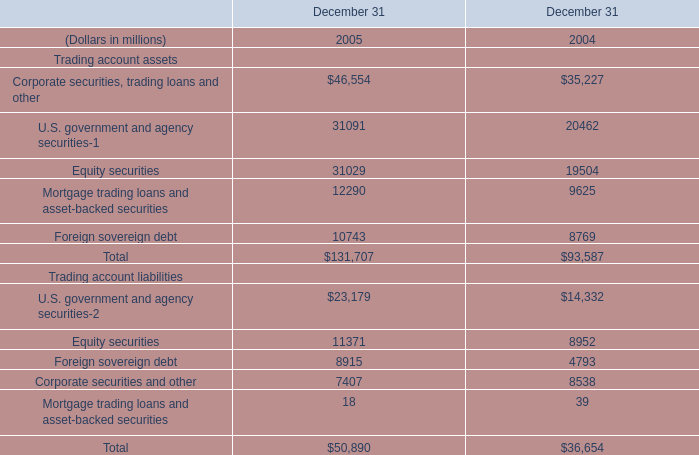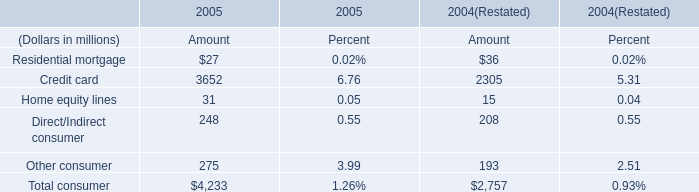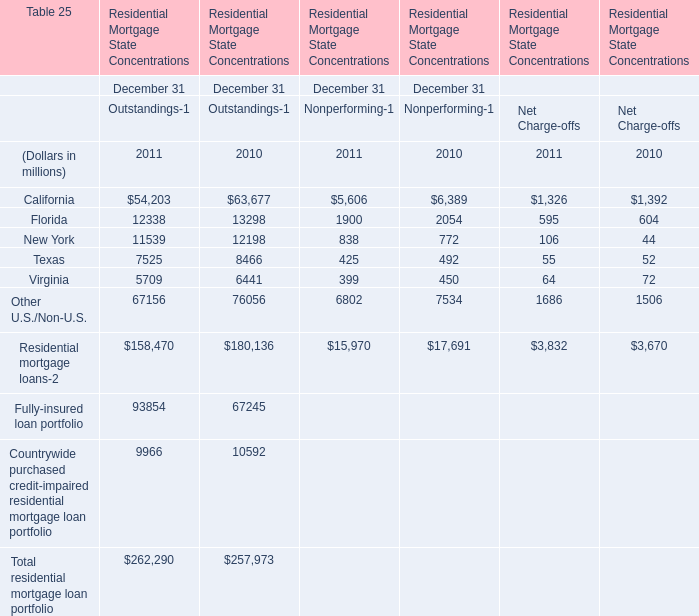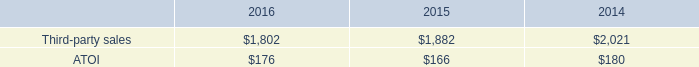considering the years 2015-2016 , how bigger is the growth of the third-party sales for the engineered products and solutions segment in comparison with the transportation and construction solutions one? 
Computations: (7% - ((1802 - 1882) / 1882))
Answer: 0.11251. 